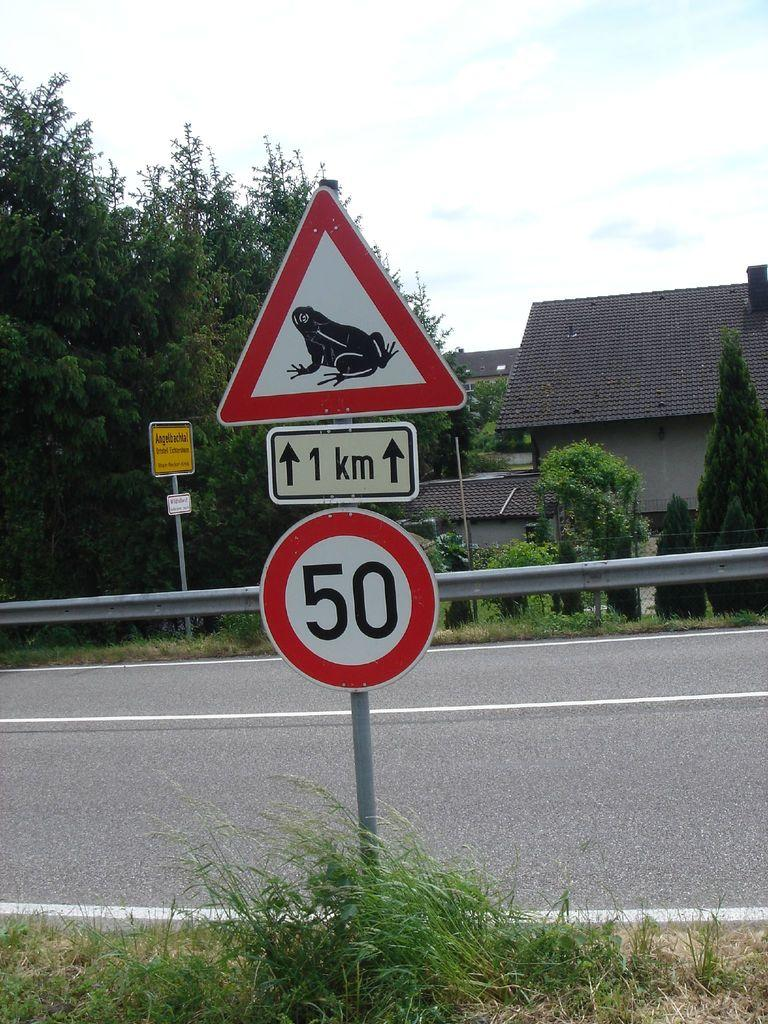Provide a one-sentence caption for the provided image. a frog on a sign with the number 50 below it. 